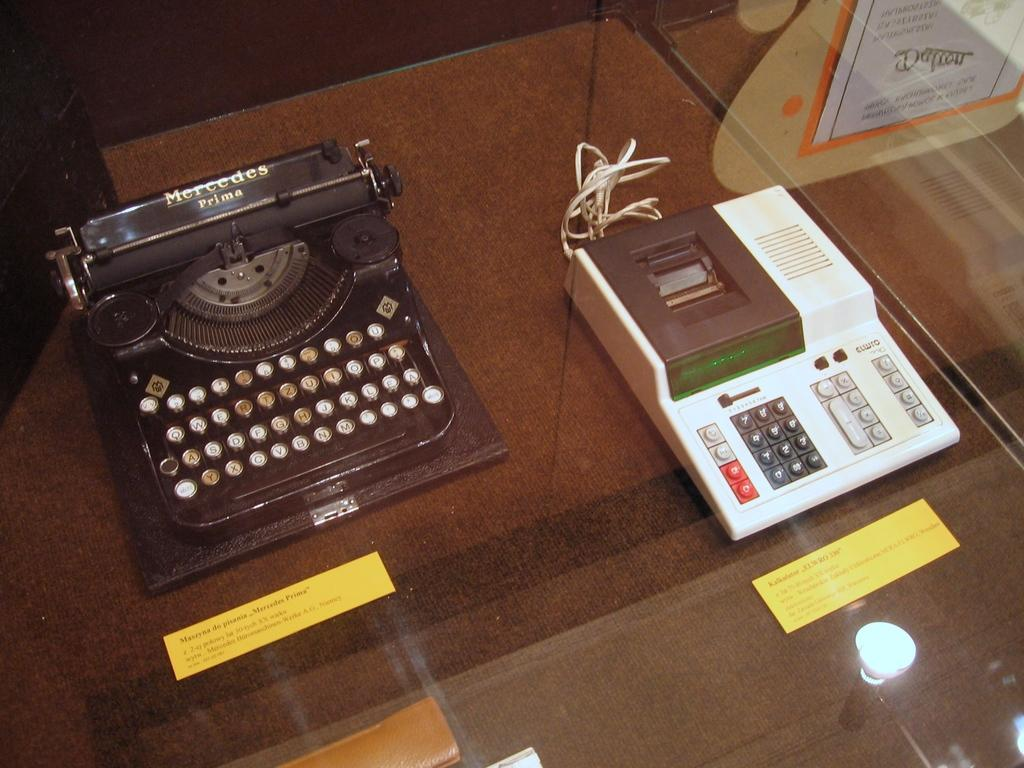<image>
Summarize the visual content of the image. A Mercedes Prima typewriter is on display with an old calculator. 